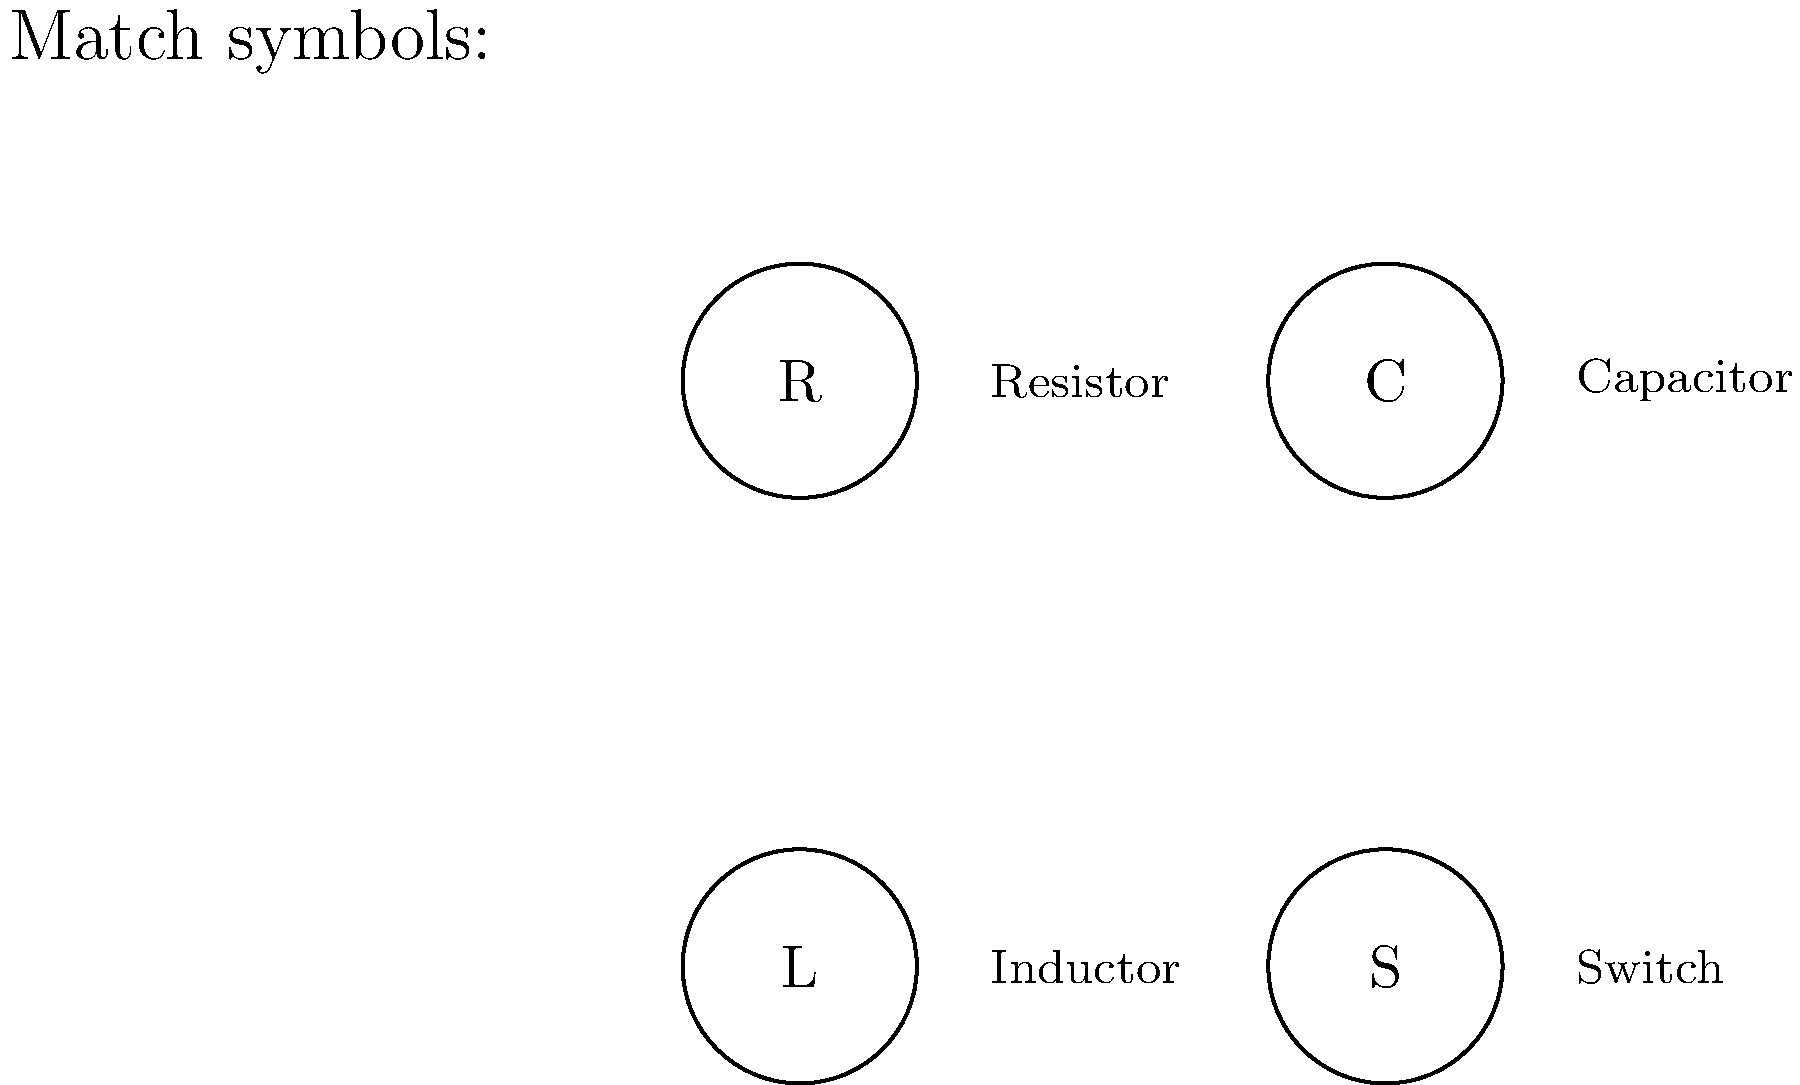Look at picture. Which symbol means "Capacitor"? Let's look at picture step by step:

1. We see 4 circles with letters inside.
2. Each circle has a name next to it.
3. The circles have these letters and names:
   - R: Resistor
   - C: Capacitor
   - L: Inductor
   - S: Switch
4. We need to find "Capacitor".
5. We can see "Capacitor" is next to the circle with "C".

So, the symbol for "Capacitor" is the circle with "C" inside.
Answer: C 